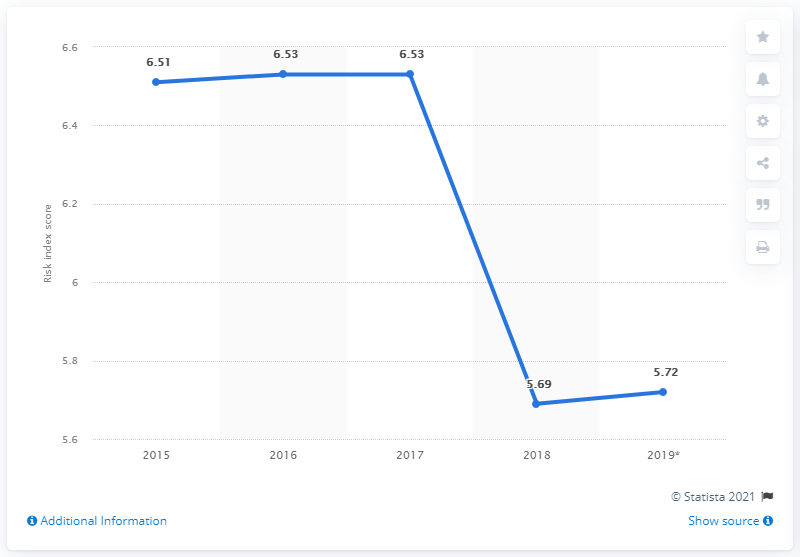Highlight a few significant elements in this photo. In 2019, Venezuela's corruption perception index score was 5.72, indicating a high level of corruption in the country. 